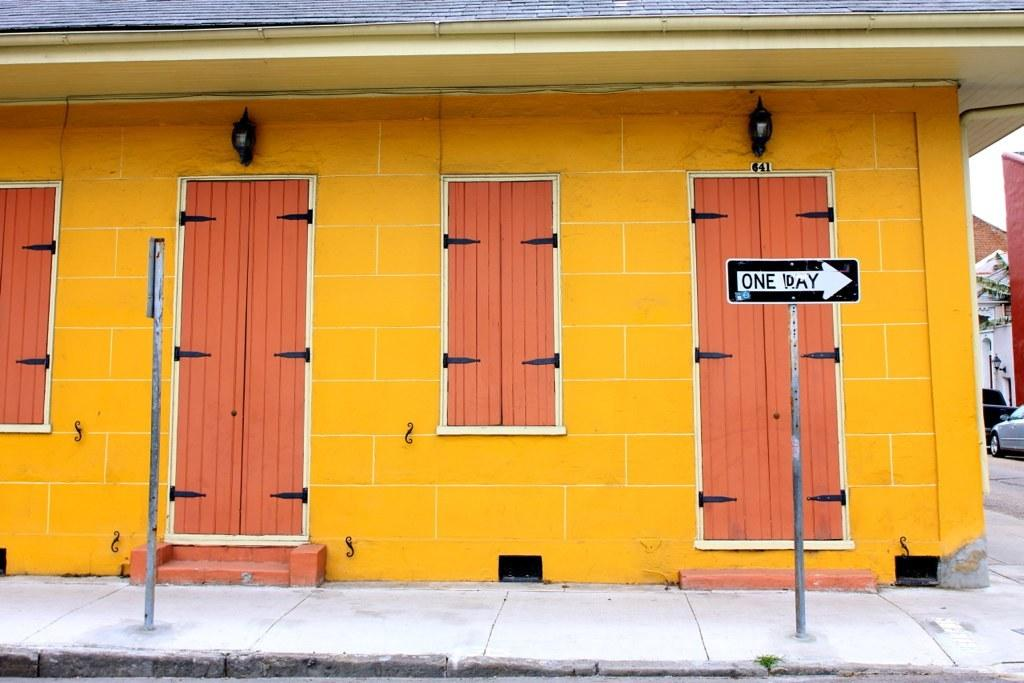What can be seen on both sides of the image? There are sign poles on both the right and left sides of the image. What is located in the center of the image? There are doors in the center of the image. Can you tell me how many boats are docked in the harbor in the image? There is no harbor or boats present in the image; it features sign poles and doors. What type of sponge is being used to clean the cellar in the image? There is no sponge or cellar present in the image. 